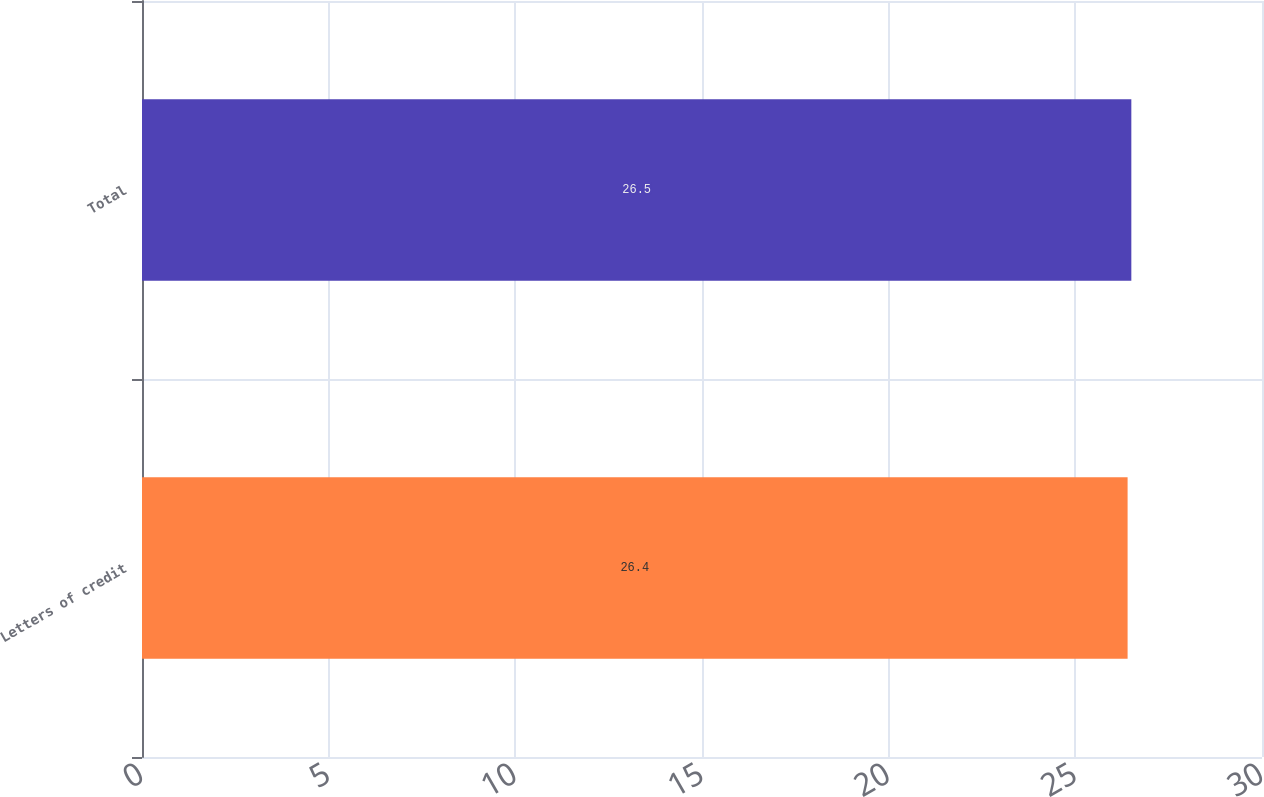Convert chart to OTSL. <chart><loc_0><loc_0><loc_500><loc_500><bar_chart><fcel>Letters of credit<fcel>Total<nl><fcel>26.4<fcel>26.5<nl></chart> 